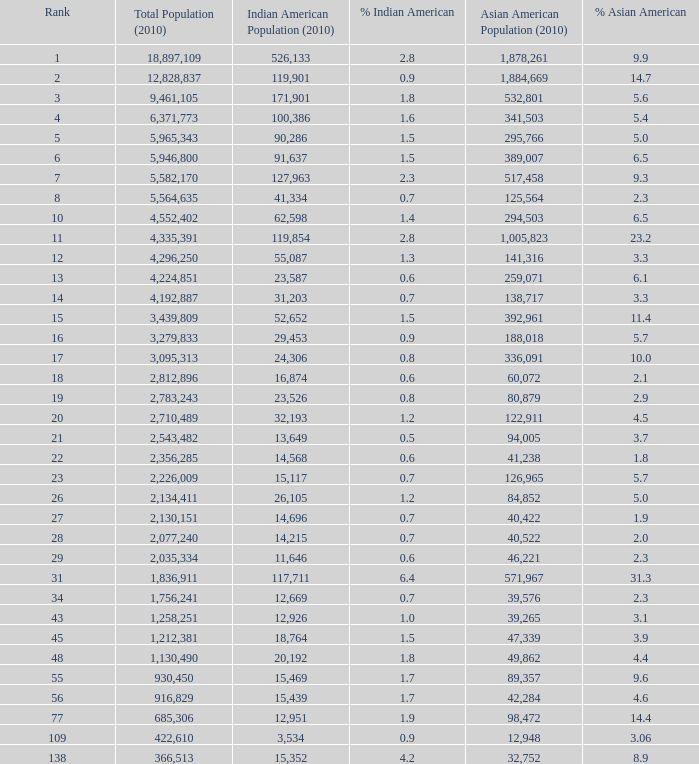What is the aggregate population when None. 